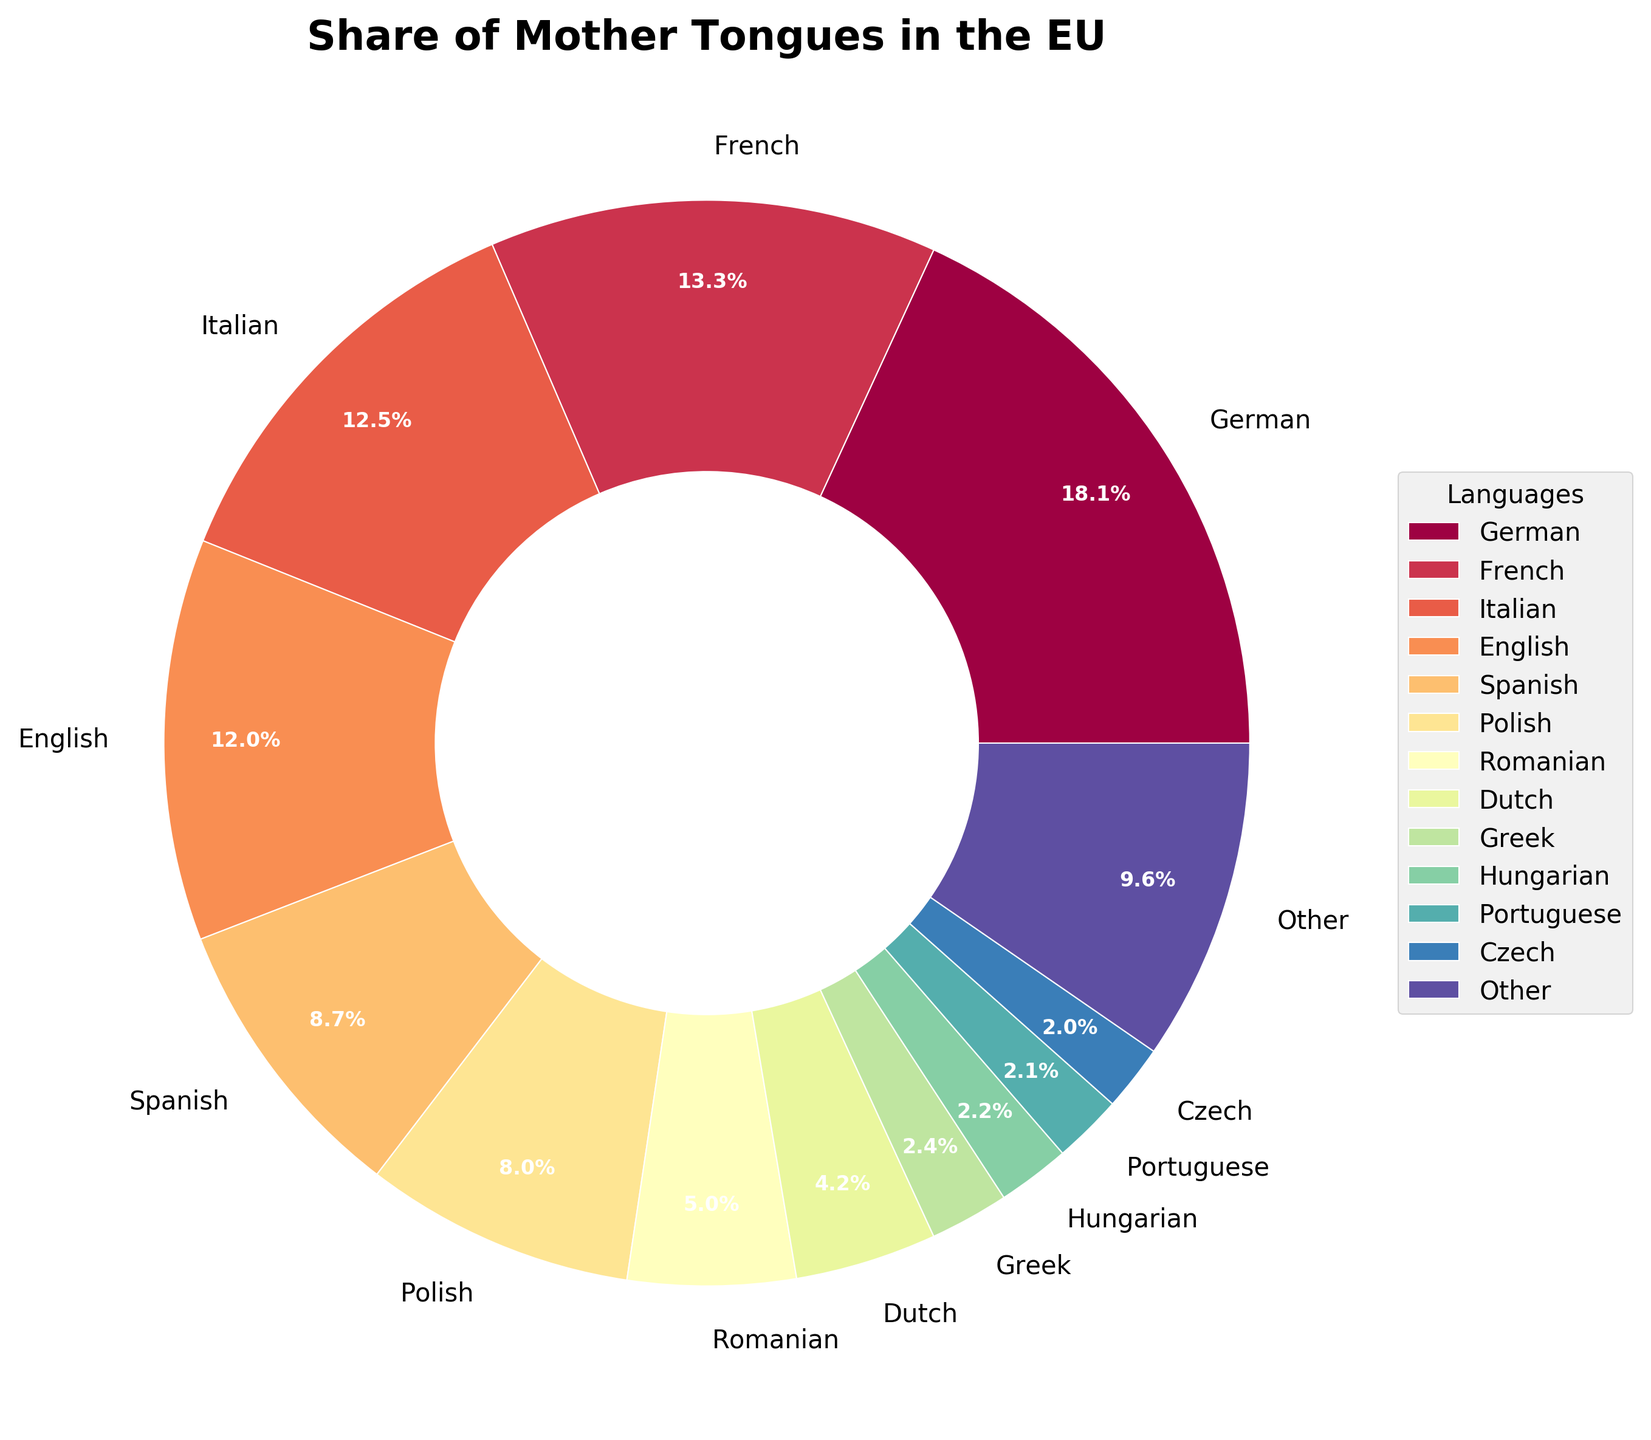What is the percentage of people who speak German as their mother tongue? The label on the pie slice for German indicates it accounts for 18.5% of the overall share
Answer: 18.5% What is the combined percentage of people who speak French and Spanish as their mother tongue? The French share is 13.6% and the Spanish share is 8.9%. Adding these together gives 13.6% + 8.9% = 22.5%
Answer: 22.5% Which language has a higher share: Italian or Dutch? The pie chart shows that Italian has a 12.7% share while Dutch has a 4.3% share. Therefore, Italian has a higher share
Answer: Italian What is the total percentage of languages spoken as mother tongues that individually have less than 2% share? The pie chart groups all these languages under "Other," which comprises 9.4% of the total share
Answer: 9.4% How does the share of Polish compare to Romanian? Polish has a share of 8.2% while Romanian has a share of 5.1%, making Polish a larger share
Answer: Polish Which languages individually make up less than 2% of the total share? Based on the pie chart, languages like Greek, Hungarian, Portuguese, Czech, Swedish, Bulgarian, Finnish, Danish, Slovak, Croatian, Lithuanian, Slovenian, Latvian, Estonian, Irish, and Maltese each individually have less than 2%
Answer: Greek, Hungarian, Portuguese, Czech, Swedish, Bulgarian, Finnish, Danish, Slovak, Croatian, Lithuanian, Slovenian, Latvian, Estonian, Irish, Maltese What is the share difference between the languages with the highest and lowest percentage? The highest share is German with 18.5%, and the lowest (individually labeled) is Maltese with 0.1%. The difference is 18.5% - 0.1% = 18.4%
Answer: 18.4% How many languages have a percentage higher than 10%? The languages with shares higher than 10% are German (18.5%), French (13.6%), Italian (12.7%), and English (12.2%). This gives us a total of 4 languages
Answer: 4 